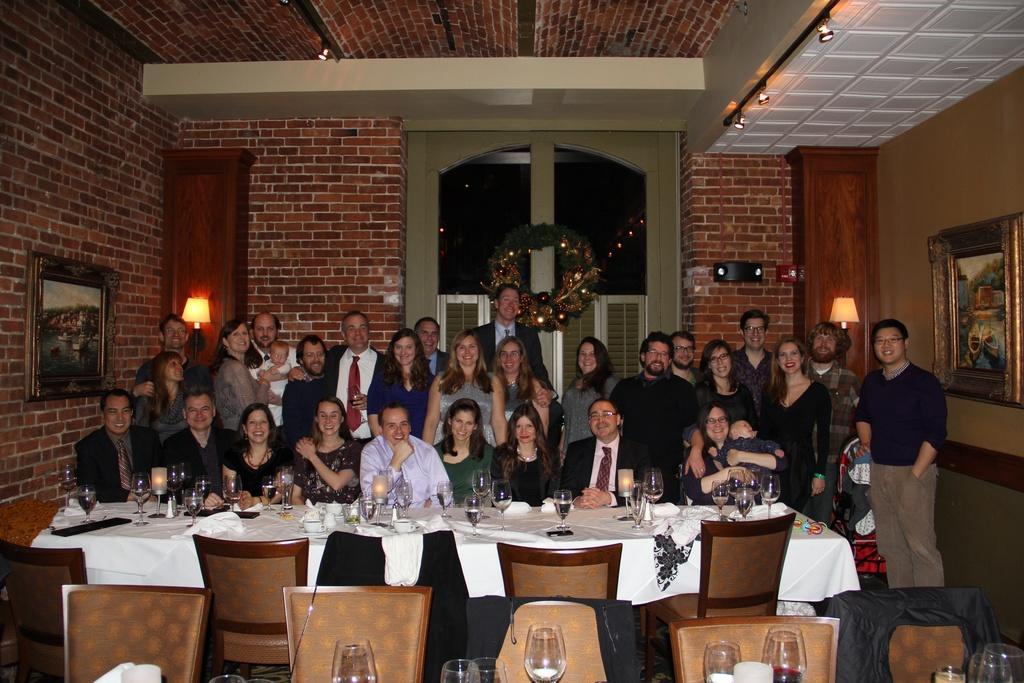Please provide a concise description of this image. In this image there are group of people. There is a table and chair. On table there is a glass,lamp,cloth. At the background we can see a wall. There is a garland on the door. The frame is attached to the wall. 